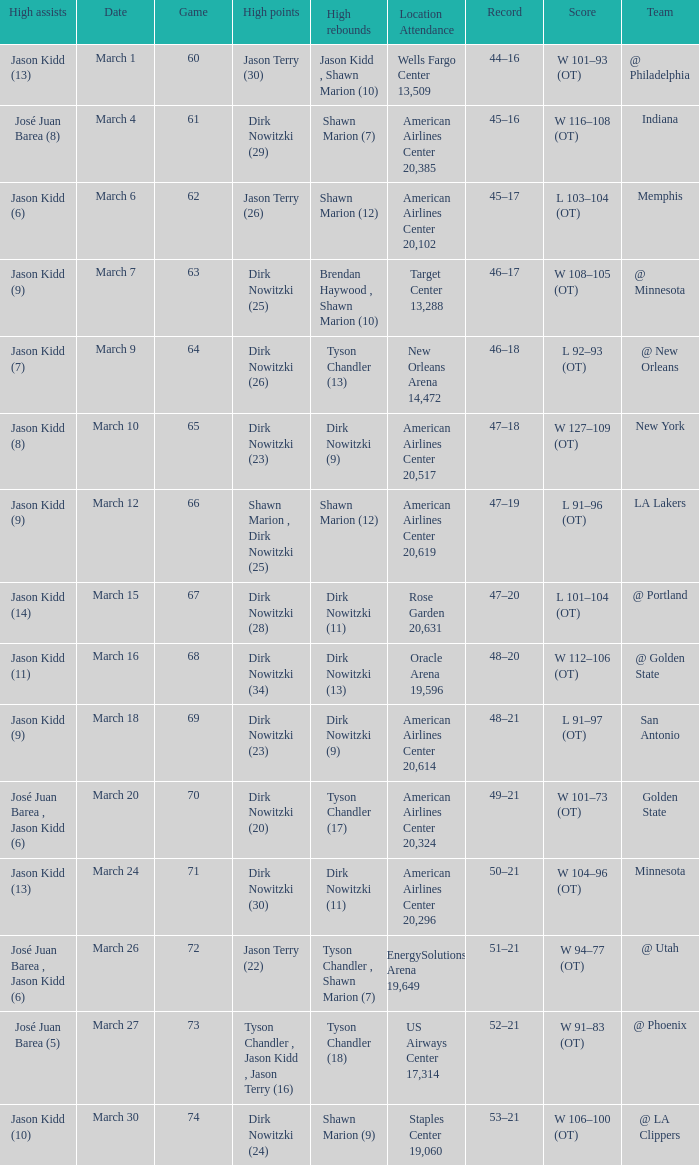Name the high points for march 30 Dirk Nowitzki (24). 